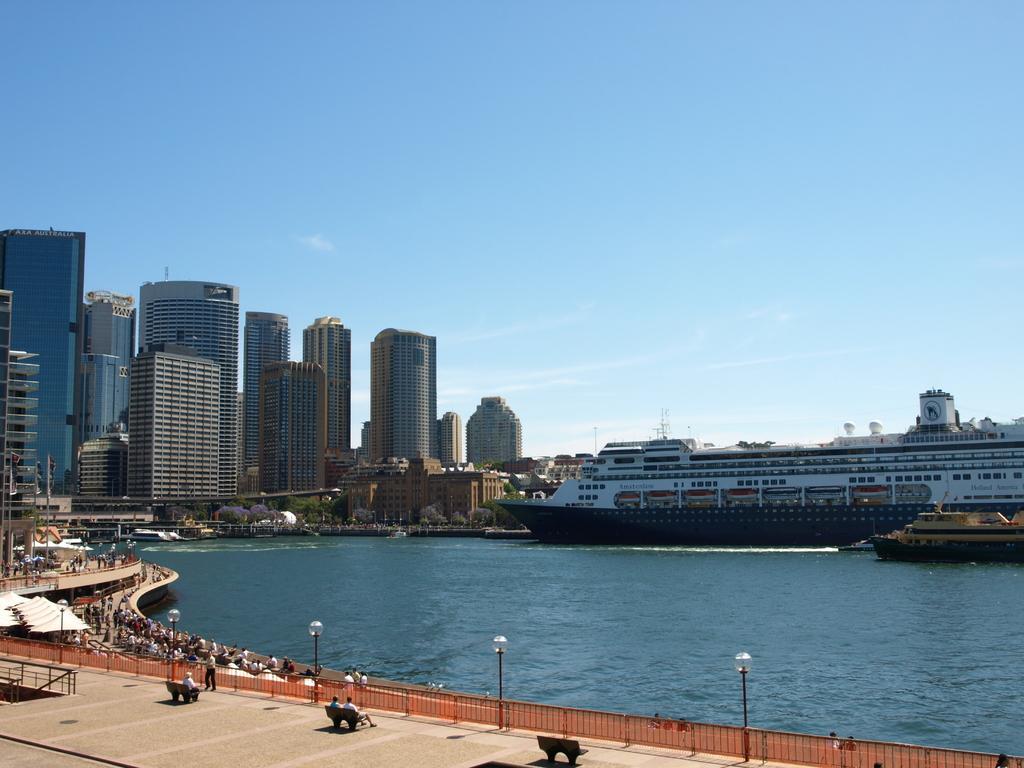Describe this image in one or two sentences. In this image we can see some buildings with windows, a group of trees and some poles, we can also see some people on the ground. In the right side of the image we can see ships in the water. In the foreground of the image we can see light poles, railing, some flags on poles and some tents. At the top of the image we can see the sky. 